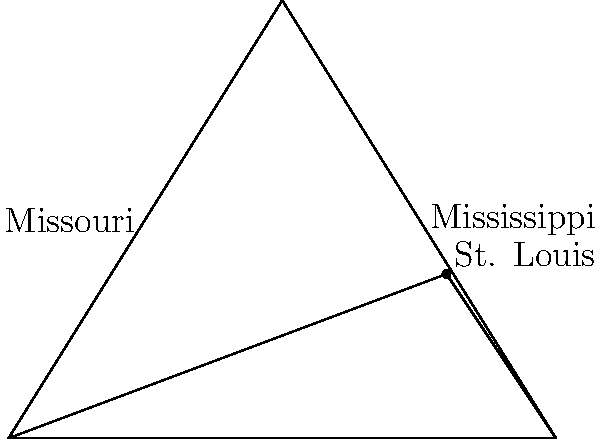In the confluence of the Mississippi and Missouri Rivers near St. Louis, which river forms the eastern boundary of the triangular area created by the two rivers and their junction point? To answer this question, let's break down the information provided in the diagram:

1. The diagram shows a triangular area formed by the confluence of two rivers.
2. The rivers are labeled as Mississippi and Missouri.
3. St. Louis is marked at the junction point of the two rivers.

Now, let's analyze the position of the rivers:

1. The Mississippi River is labeled on the right side of the triangle.
2. The Missouri River is labeled on the left side of the triangle.

In geographic terms:
1. East is typically represented on the right side of a map.
2. West is typically represented on the left side of a map.

Therefore, since the Mississippi River is on the right side of the triangle, it forms the eastern boundary of the triangular area created by the two rivers and their junction point at St. Louis.
Answer: Mississippi River 